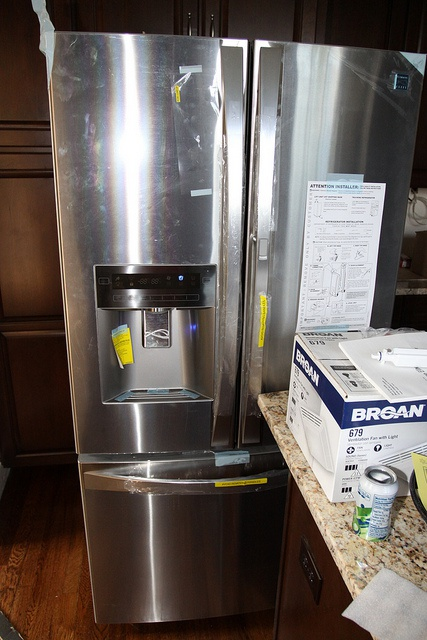Describe the objects in this image and their specific colors. I can see a refrigerator in black, gray, lightgray, and darkgray tones in this image. 